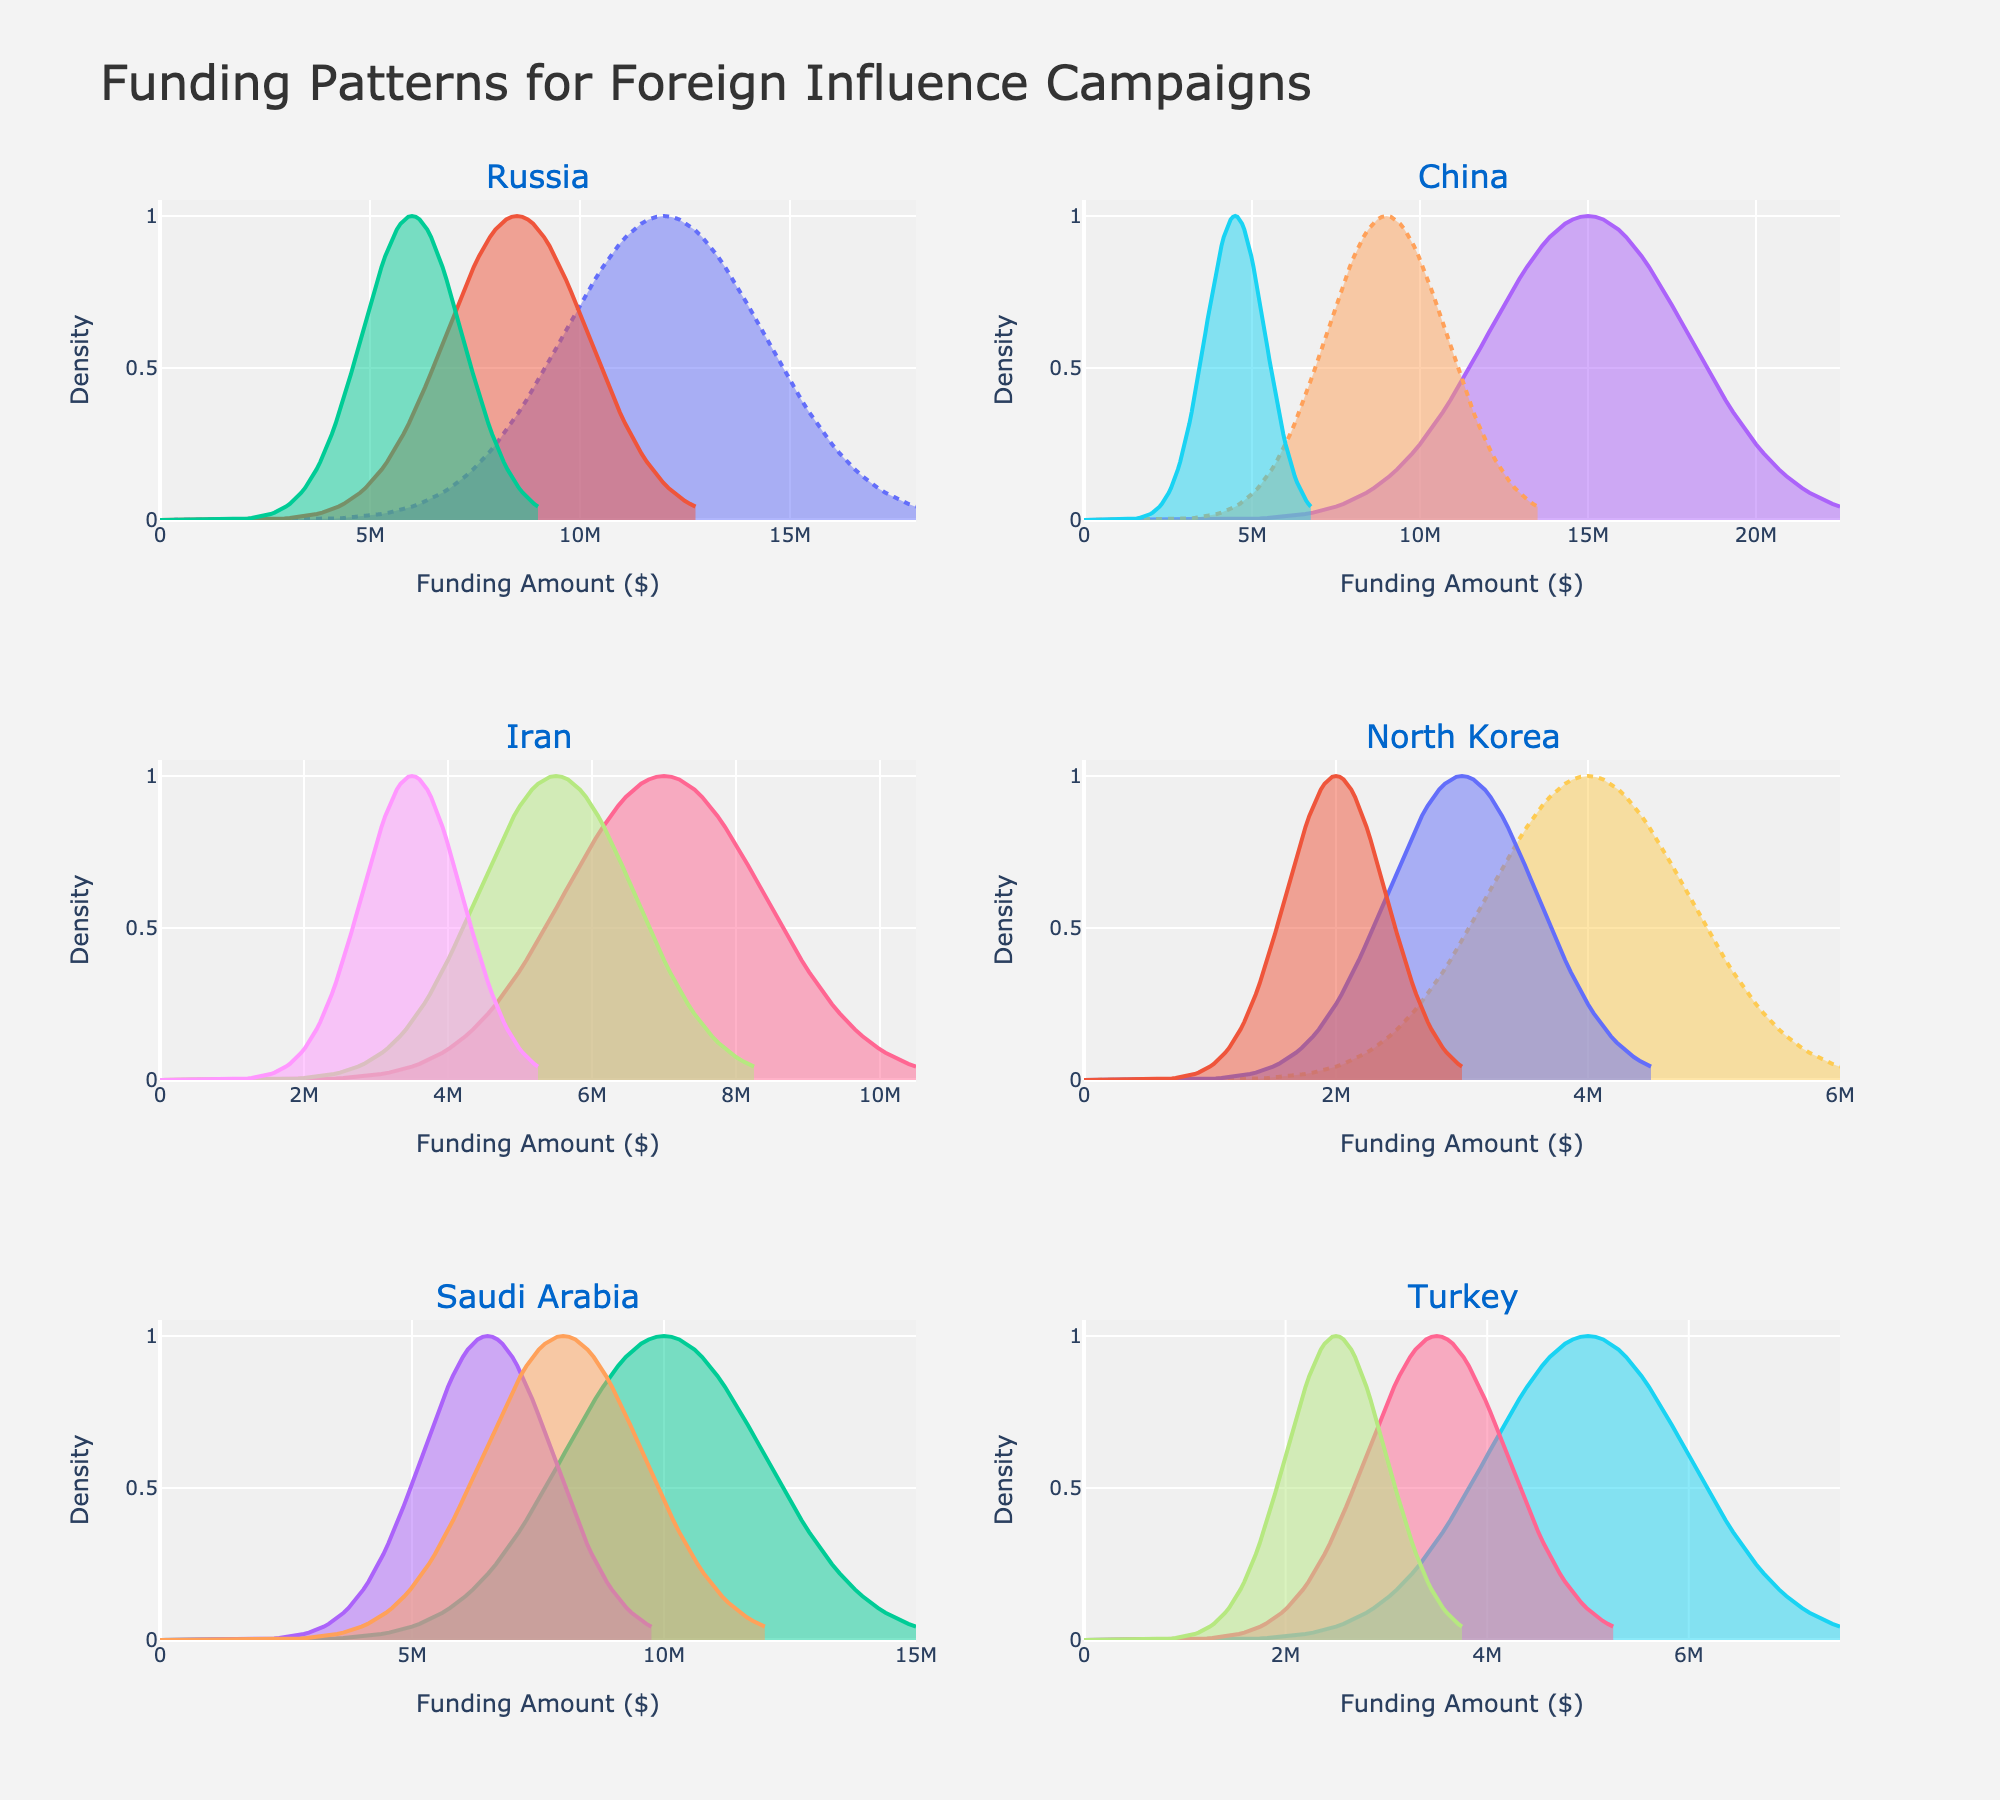What is the total funding amount for influence campaigns from Russia? To find the total funding amount for influence campaigns from Russia, add up the amounts for all funding sources: State-sponsored (12,000,000), Oligarchs (8,500,000), and Front organizations (6,000,000). The sum is 12,000,000 + 8,500,000 + 6,000,000 = 26,500,000.
Answer: 26,500,000 Which country has the highest single source of funding for influence campaigns? To determine which country has the highest single source of funding, we look at the maximum funding amount from each funding source across all countries. Notable amounts include China (Government agencies with 15,000,000).
Answer: China What is the average funding amount across all funding sources from Iran? To find the average funding amount, first calculate the total amount from Iran's funding sources: Revolutionary Guard (7,000,000), Religious foundations (5,500,000), and Proxy groups (3,500,000). The total sum is 7,000,000 + 5,500,000 + 3,500,000 = 16,000,000. Since there are three sources, the average is 16,000,000 / 3 = 5,333,333.33.
Answer: 5,333,333.33 Which funding source within Saudi Arabia has the highest density peak? Saudi Arabia's funding sources include the Royal family, Religious charities, and Sovereign wealth fund. By observing the density plots for Saudi Arabia, the plot with the highest peak assists in identifying that source.
Answer: Royal family How does the distribution of funding sources from North Korea compare to Turkey? Compare the shape and spread of the density curves for North Korea (State budget, Cyber operations, Overseas workers) and Turkey (Government ministries, Media conglomerates, Diaspora organizations). North Korea's distributions are more close to each other in terms of amount, whereas Turkey has a wider range and more distinct peaks.
Answer: North Korea funding sources have closer amounts, Turkey has a wider range What is the most prominent funding source for China based on the density plots? By examining the density plots specific to China, observe the peak height which indicates the most prominent funding source. The plot with the highest peak represents Government agencies.
Answer: Government agencies Which two countries have the most similar funding amounts for state-related sources? Compare the funding amounts for "state-related" sources of each country. Focus on Russia (State-sponsored, 12,000,000) and China (Government agencies, 15,000,000). Despite differing amounts, these figures are the closest relative to other countries' state-related sources.
Answer: Russia and China Is the density peak for the Iranian Proxy groups higher than the Cyber operations in North Korea? Observe the density plots for the Iranian Proxy groups and North Korea's Cyber operations. Compare their peak heights to ascertain the higher one.
Answer: No 